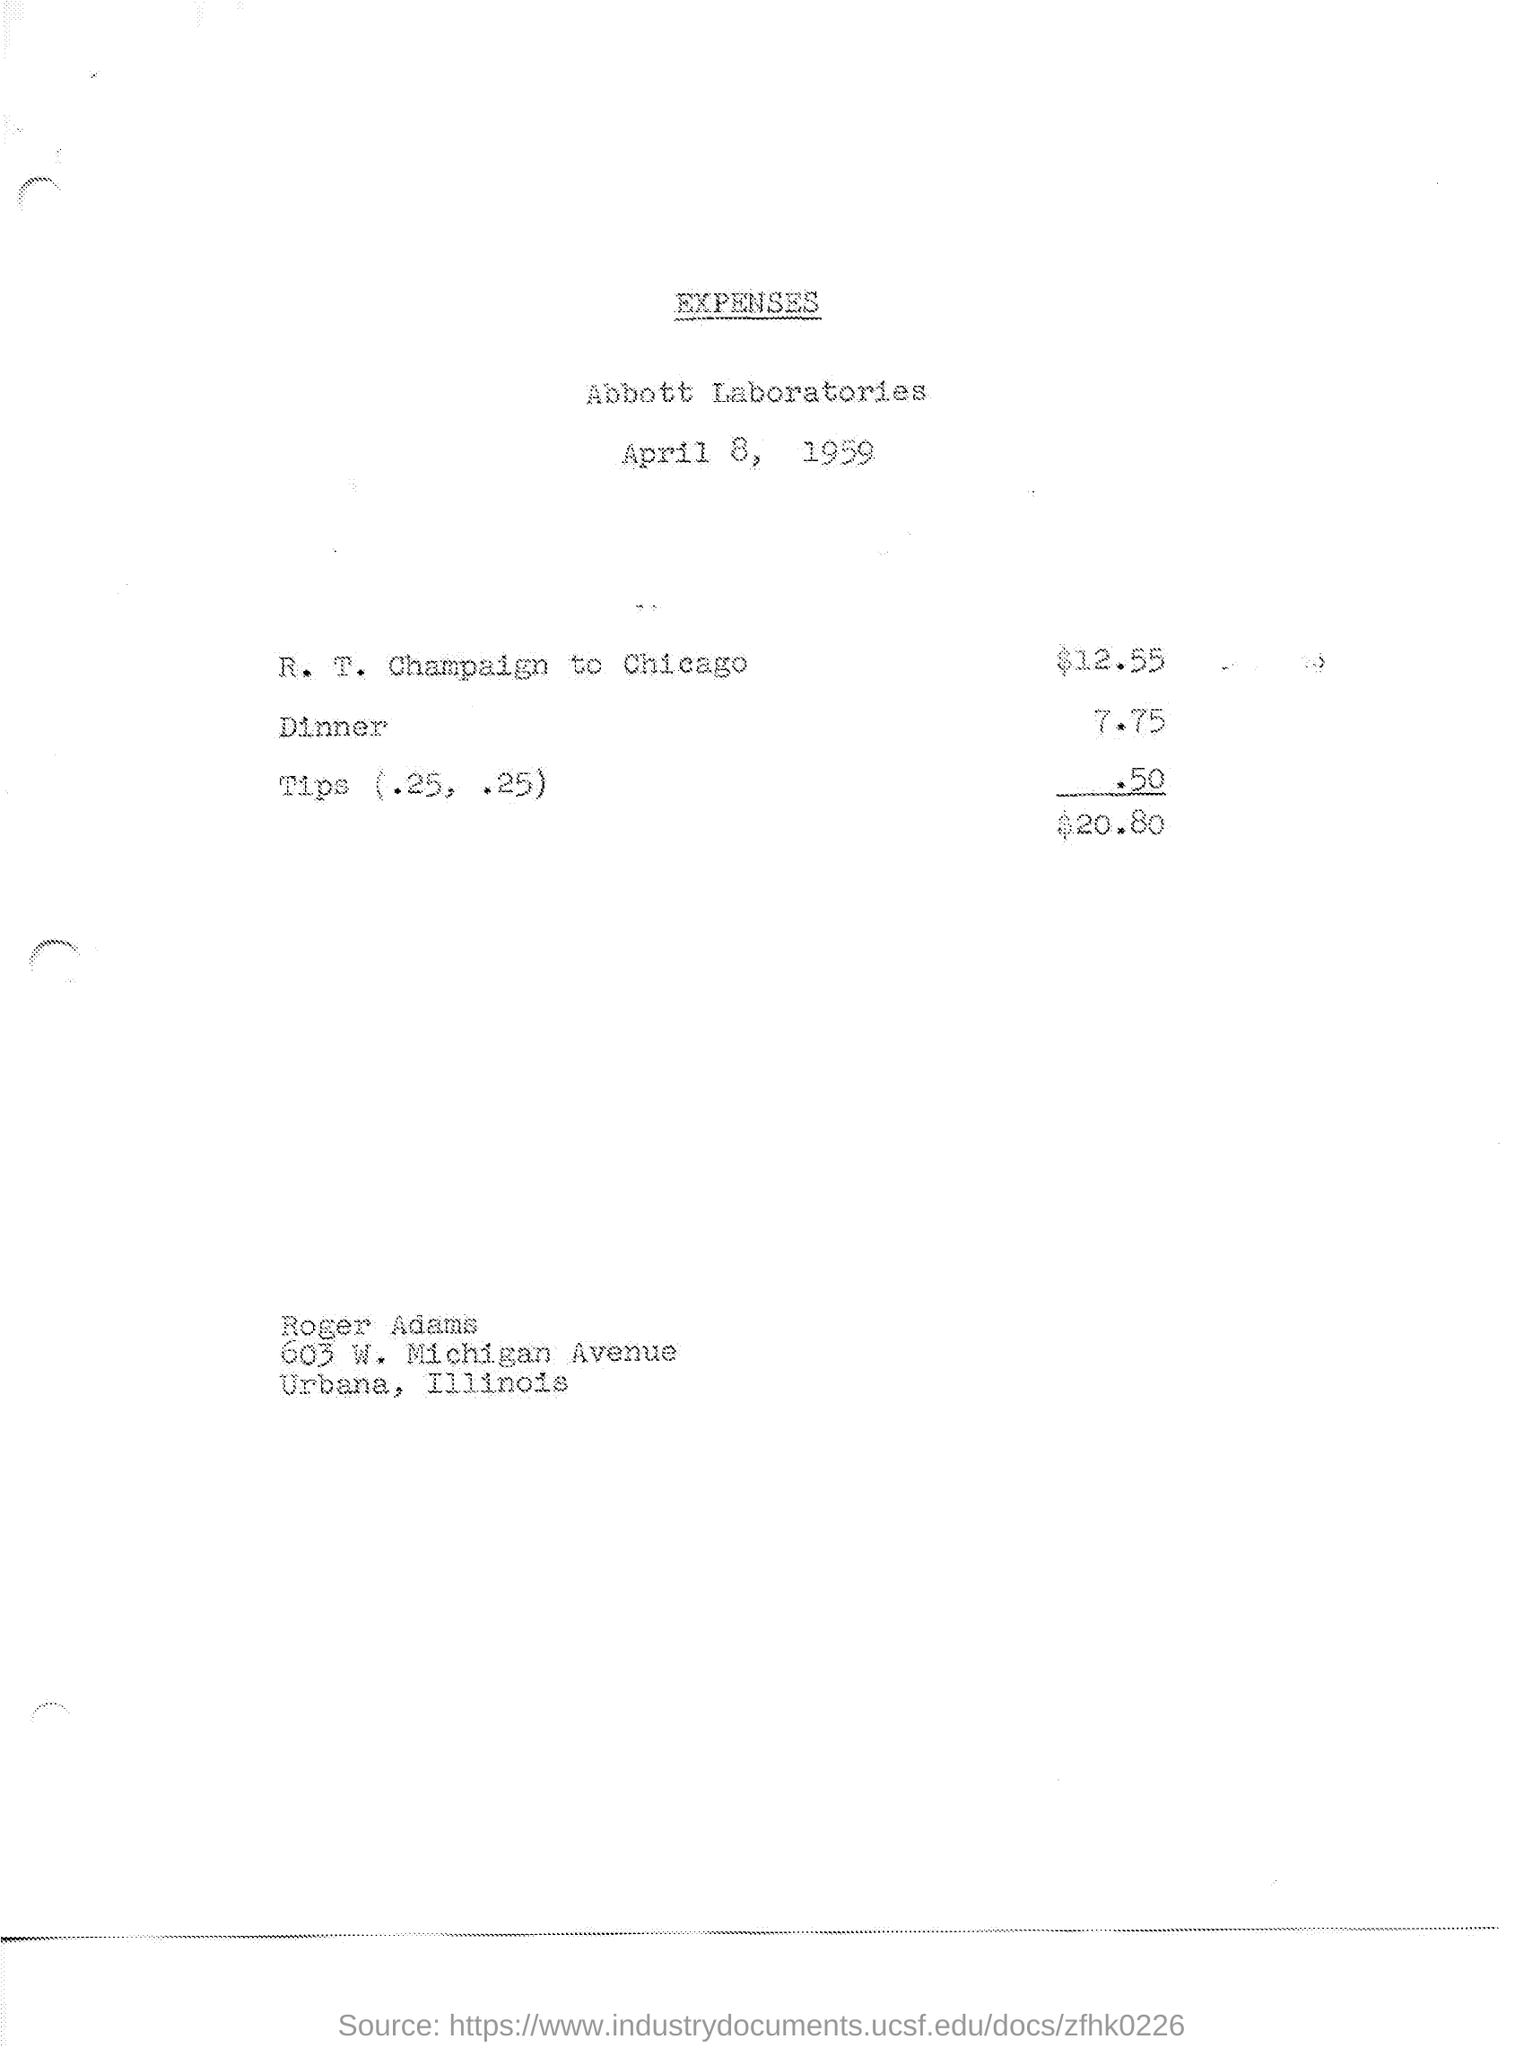What is tips amount?
 .50 